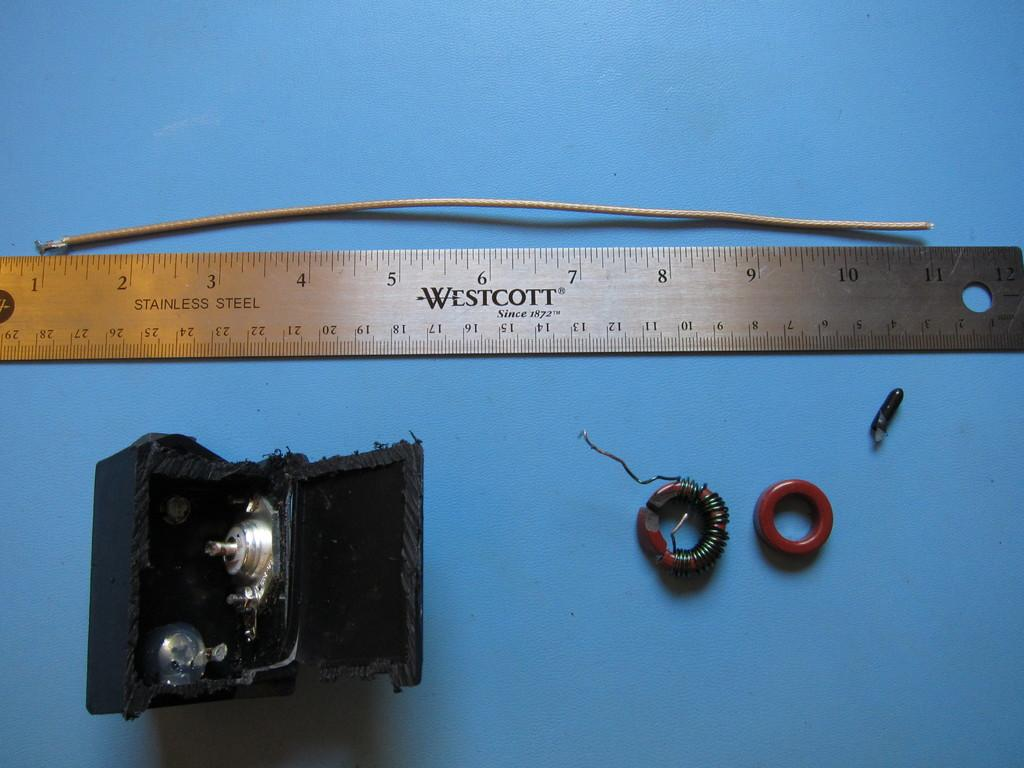Provide a one-sentence caption for the provided image. A stainless steel ruler is made by the Westcott company, which has been in business since 1872. 